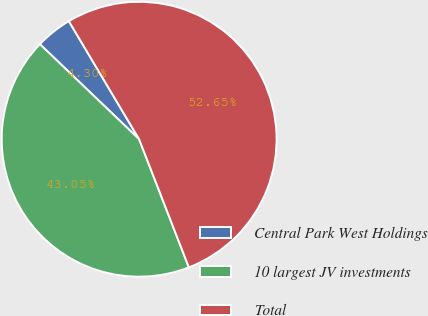Convert chart to OTSL. <chart><loc_0><loc_0><loc_500><loc_500><pie_chart><fcel>Central Park West Holdings<fcel>10 largest JV investments<fcel>Total<nl><fcel>4.3%<fcel>43.05%<fcel>52.65%<nl></chart> 